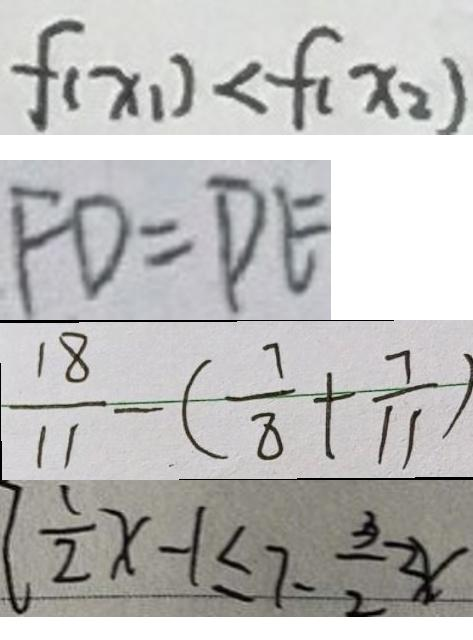Convert formula to latex. <formula><loc_0><loc_0><loc_500><loc_500>f ( x _ { 1 } ) < f ( x _ { 2 } ) 
 F D = D E 
 \frac { 1 8 } { 1 1 } - ( \frac { 7 } { 8 } + \frac { 7 } { 1 1 } ) 
 \frac { 1 } { 2 } x - 1 \leq 7 - \frac { 3 } { 2 } \geq x</formula> 